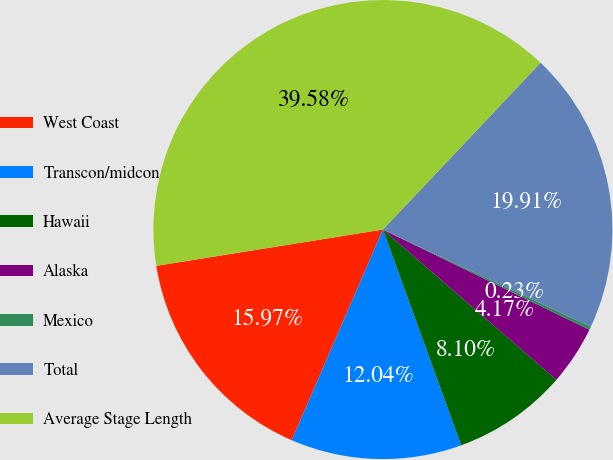<chart> <loc_0><loc_0><loc_500><loc_500><pie_chart><fcel>West Coast<fcel>Transcon/midcon<fcel>Hawaii<fcel>Alaska<fcel>Mexico<fcel>Total<fcel>Average Stage Length<nl><fcel>15.97%<fcel>12.04%<fcel>8.1%<fcel>4.17%<fcel>0.23%<fcel>19.91%<fcel>39.58%<nl></chart> 